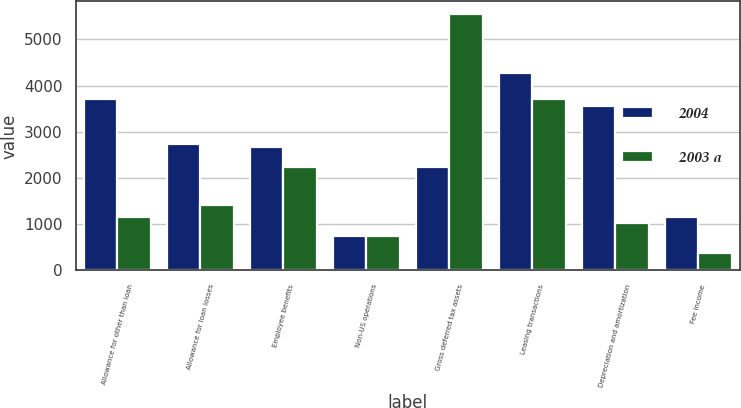<chart> <loc_0><loc_0><loc_500><loc_500><stacked_bar_chart><ecel><fcel>Allowance for other than loan<fcel>Allowance for loan losses<fcel>Employee benefits<fcel>Non-US operations<fcel>Gross deferred tax assets<fcel>Leasing transactions<fcel>Depreciation and amortization<fcel>Fee income<nl><fcel>2004<fcel>3711<fcel>2739<fcel>2677<fcel>743<fcel>2245<fcel>4266<fcel>3558<fcel>1162<nl><fcel>2003 a<fcel>1152<fcel>1410<fcel>2245<fcel>741<fcel>5548<fcel>3703<fcel>1037<fcel>387<nl></chart> 